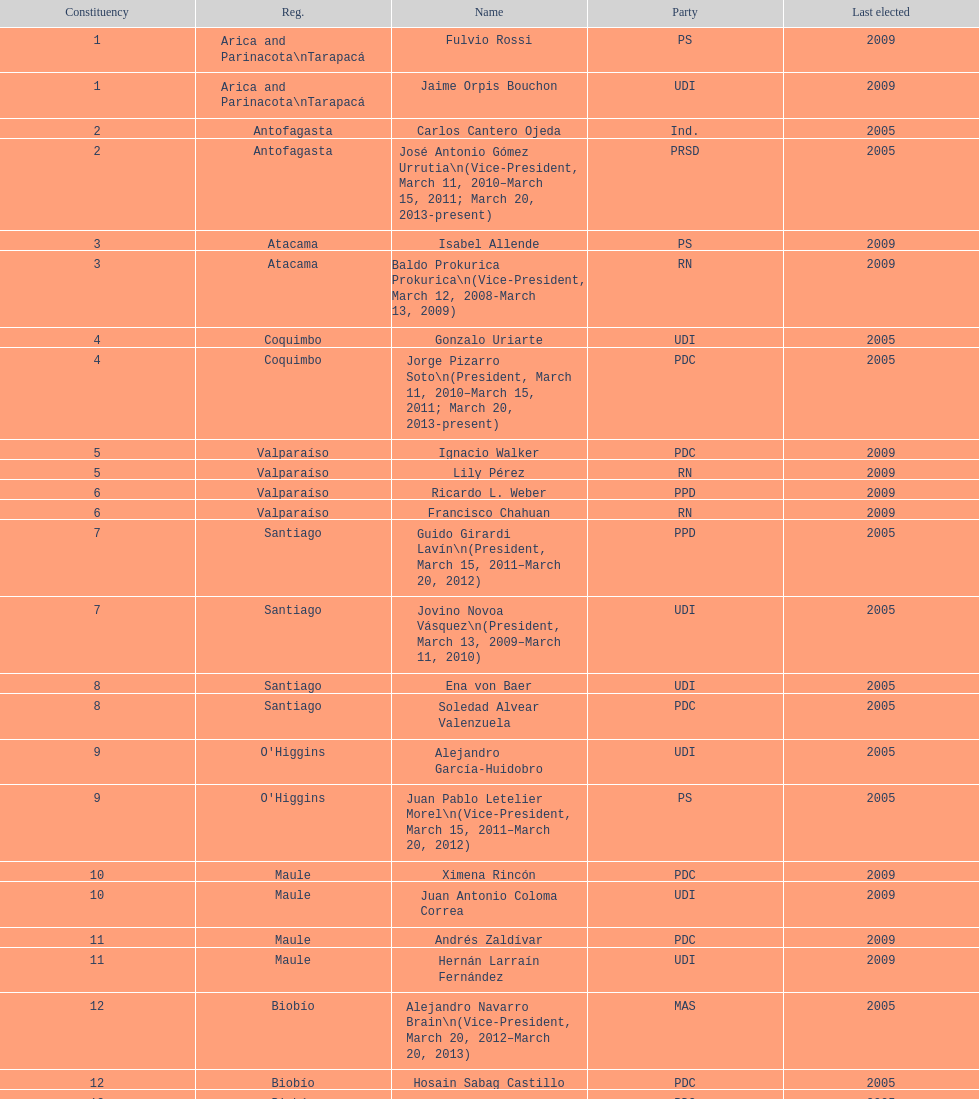How long was baldo prokurica prokurica vice-president? 1 year. 